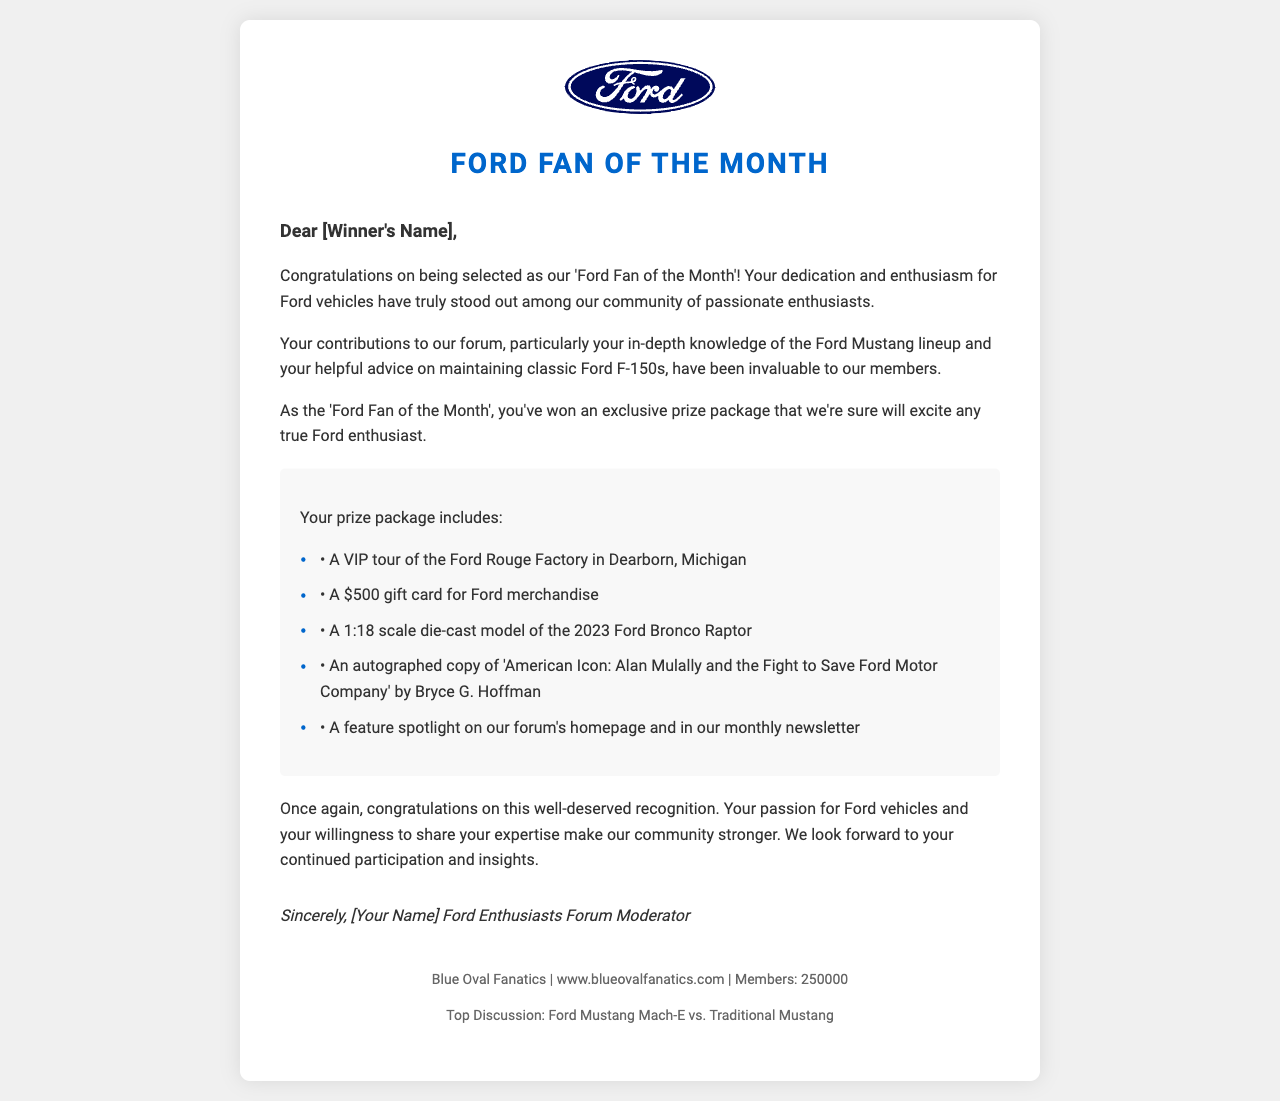What is the winner's favorite model? The favorite model is mentioned in the winner profile section of the document.
Answer: 1967 Ford Mustang Shelby GT500 What is the date of the Ford Nationals event? The event date is provided in the upcoming Ford events section of the document.
Answer: June 2-4, 2023 What prize includes a VIP tour? The specific prize offering a VIP tour is detailed in the list within the body paragraphs.
Answer: A VIP tour of the Ford Rouge Factory in Dearborn, Michigan How many posts has the winner contributed? The number of posts is listed in the winner profile section of the document.
Answer: 1500 What title has the winner received? The title is referenced in the opening paragraph of the letter.
Answer: Ford Fan of the Month What is the total number of members in the forum? The total number of forum members is mentioned in the footer of the document.
Answer: 250000 Who authored the book included in the prize package? The author of the book is specified in the prize package details.
Answer: Bryce G. Hoffman What is the purpose of the letter? The purpose is indicated in the opening paragraph of the document.
Answer: Congratulatory message What is included in the monthly newsletter? The content mentioned pertains to the recognition given to the winner.
Answer: A feature spotlight on our forum's homepage and in our monthly newsletter 